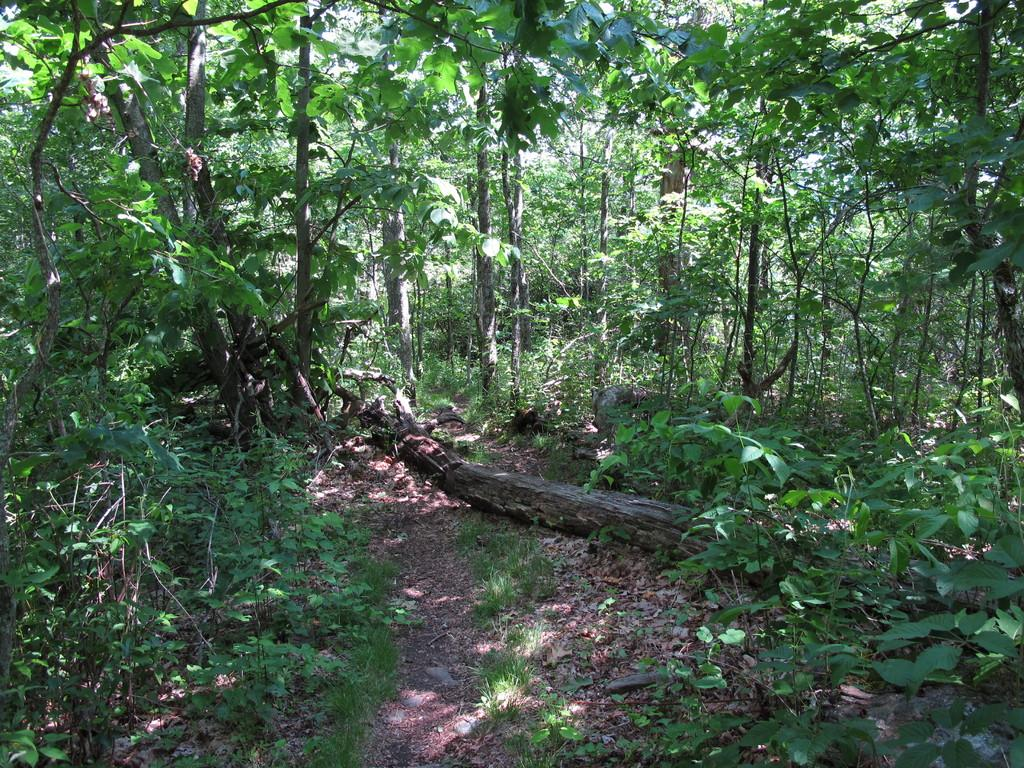What type of vegetation can be seen in the image? There are trees and plants in the image. Can you describe the tree trunk in the image? There is a tree trunk on the ground in the image. How many turkeys can be seen perched on the tree branches in the image? There are no turkeys present in the image; it features trees and plants. What type of tooth is visible in the image? There are no teeth present in the image, as it features trees and plants. 